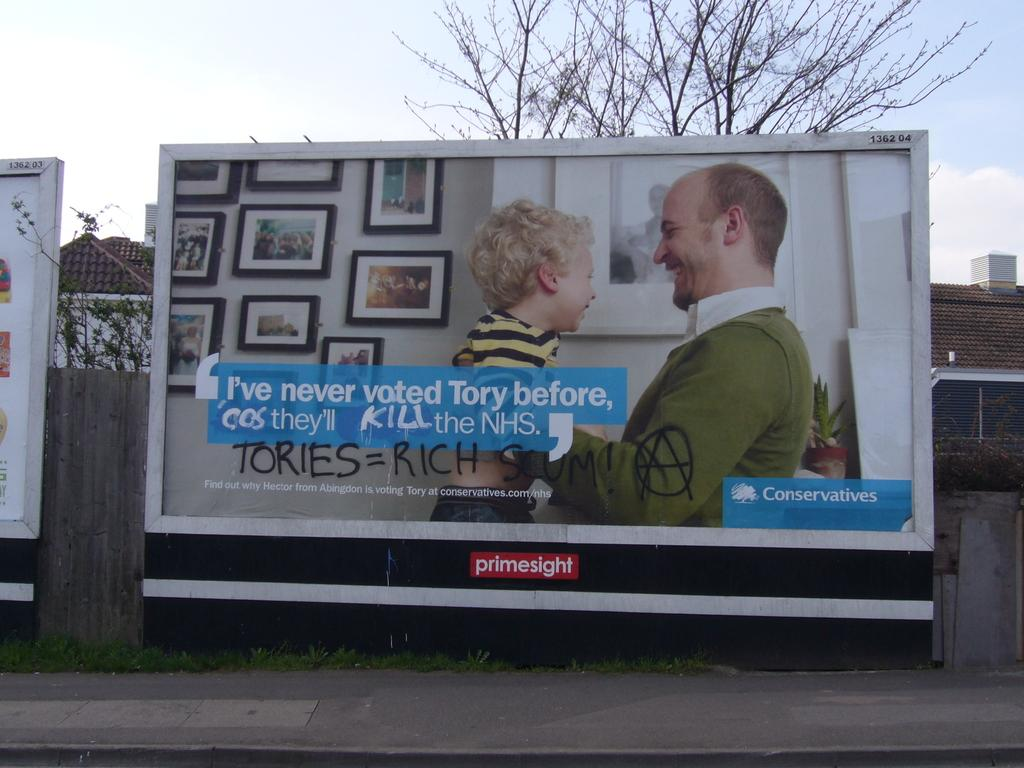<image>
Write a terse but informative summary of the picture. A conservatives billboard has been vandalized in town. 